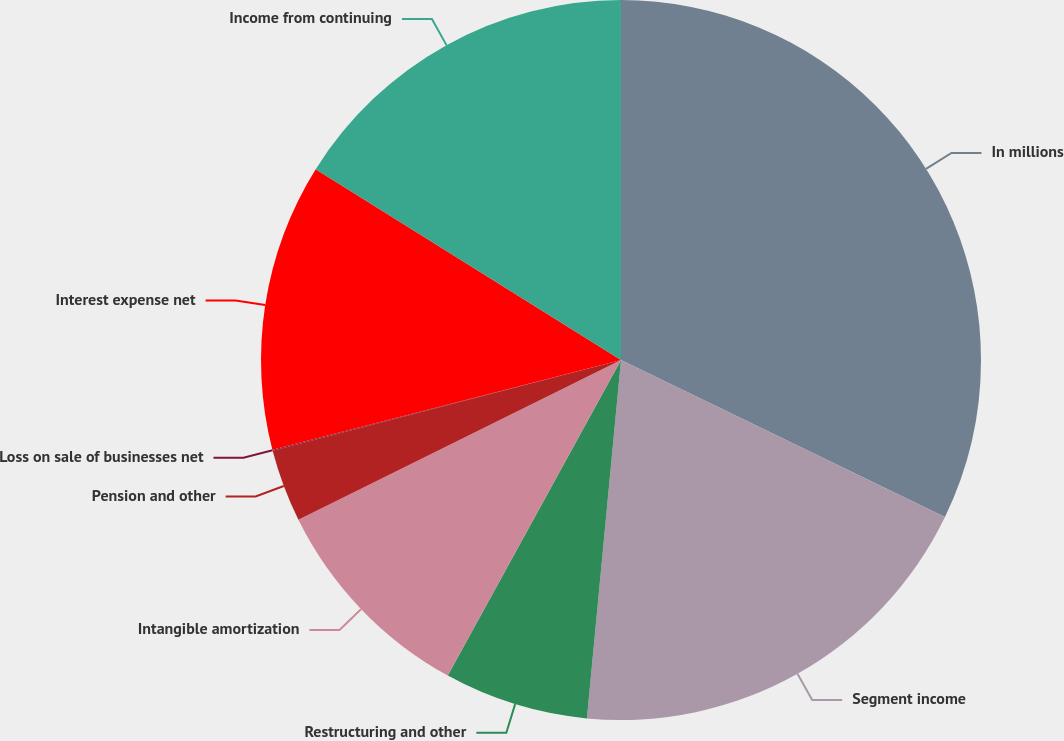Convert chart to OTSL. <chart><loc_0><loc_0><loc_500><loc_500><pie_chart><fcel>In millions<fcel>Segment income<fcel>Restructuring and other<fcel>Intangible amortization<fcel>Pension and other<fcel>Loss on sale of businesses net<fcel>Interest expense net<fcel>Income from continuing<nl><fcel>32.18%<fcel>19.33%<fcel>6.48%<fcel>9.69%<fcel>3.26%<fcel>0.05%<fcel>12.9%<fcel>16.11%<nl></chart> 